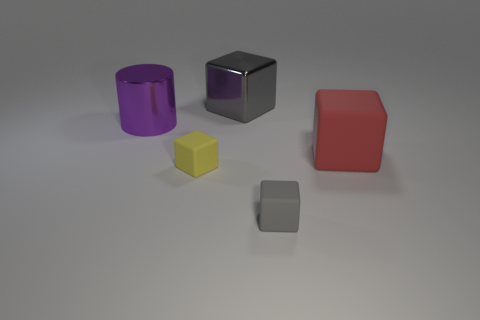Are there any patterns or designs on any of the objects? No, all of the objects have solid colors without any additional patterns or designs, providing a minimalist aesthetic. Can you tell which object is in the foreground? Certainly, the small yellow cube is placed in the foreground, closer to the viewer's perspective. 